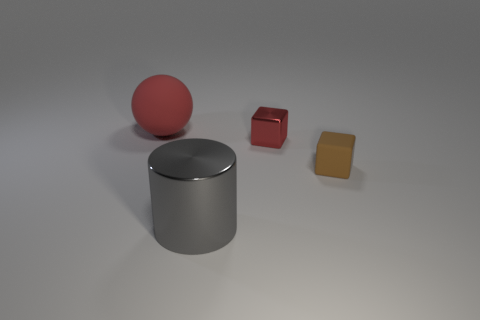What number of things are either tiny blocks or big objects to the left of the big metal object?
Your answer should be very brief. 3. How big is the thing that is to the left of the red metal object and behind the large gray metal object?
Give a very brief answer. Large. Are there more tiny brown cubes that are to the right of the small brown cube than big things that are behind the tiny red metallic cube?
Offer a terse response. No. Do the small brown object and the metal object that is in front of the tiny brown rubber block have the same shape?
Offer a terse response. No. How many other objects are there of the same shape as the tiny brown rubber object?
Make the answer very short. 1. What color is the object that is both in front of the tiny red thing and right of the big metal object?
Give a very brief answer. Brown. What is the color of the matte sphere?
Your answer should be compact. Red. Is the brown cube made of the same material as the big object that is behind the cylinder?
Offer a terse response. Yes. What shape is the small brown object that is made of the same material as the red sphere?
Make the answer very short. Cube. What color is the other thing that is the same size as the red matte thing?
Give a very brief answer. Gray. 